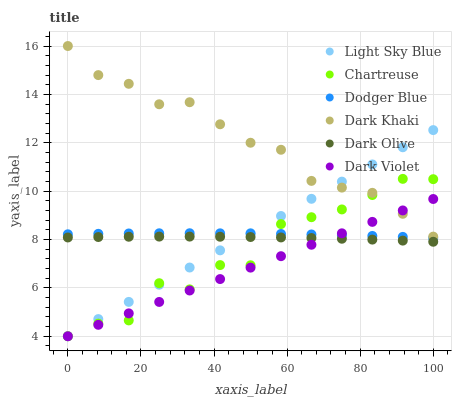Does Dark Violet have the minimum area under the curve?
Answer yes or no. Yes. Does Dark Khaki have the maximum area under the curve?
Answer yes or no. Yes. Does Dark Khaki have the minimum area under the curve?
Answer yes or no. No. Does Dark Violet have the maximum area under the curve?
Answer yes or no. No. Is Light Sky Blue the smoothest?
Answer yes or no. Yes. Is Chartreuse the roughest?
Answer yes or no. Yes. Is Dark Violet the smoothest?
Answer yes or no. No. Is Dark Violet the roughest?
Answer yes or no. No. Does Dark Violet have the lowest value?
Answer yes or no. Yes. Does Dark Khaki have the lowest value?
Answer yes or no. No. Does Dark Khaki have the highest value?
Answer yes or no. Yes. Does Dark Violet have the highest value?
Answer yes or no. No. Is Dark Olive less than Dodger Blue?
Answer yes or no. Yes. Is Dark Khaki greater than Dark Olive?
Answer yes or no. Yes. Does Light Sky Blue intersect Dodger Blue?
Answer yes or no. Yes. Is Light Sky Blue less than Dodger Blue?
Answer yes or no. No. Is Light Sky Blue greater than Dodger Blue?
Answer yes or no. No. Does Dark Olive intersect Dodger Blue?
Answer yes or no. No. 